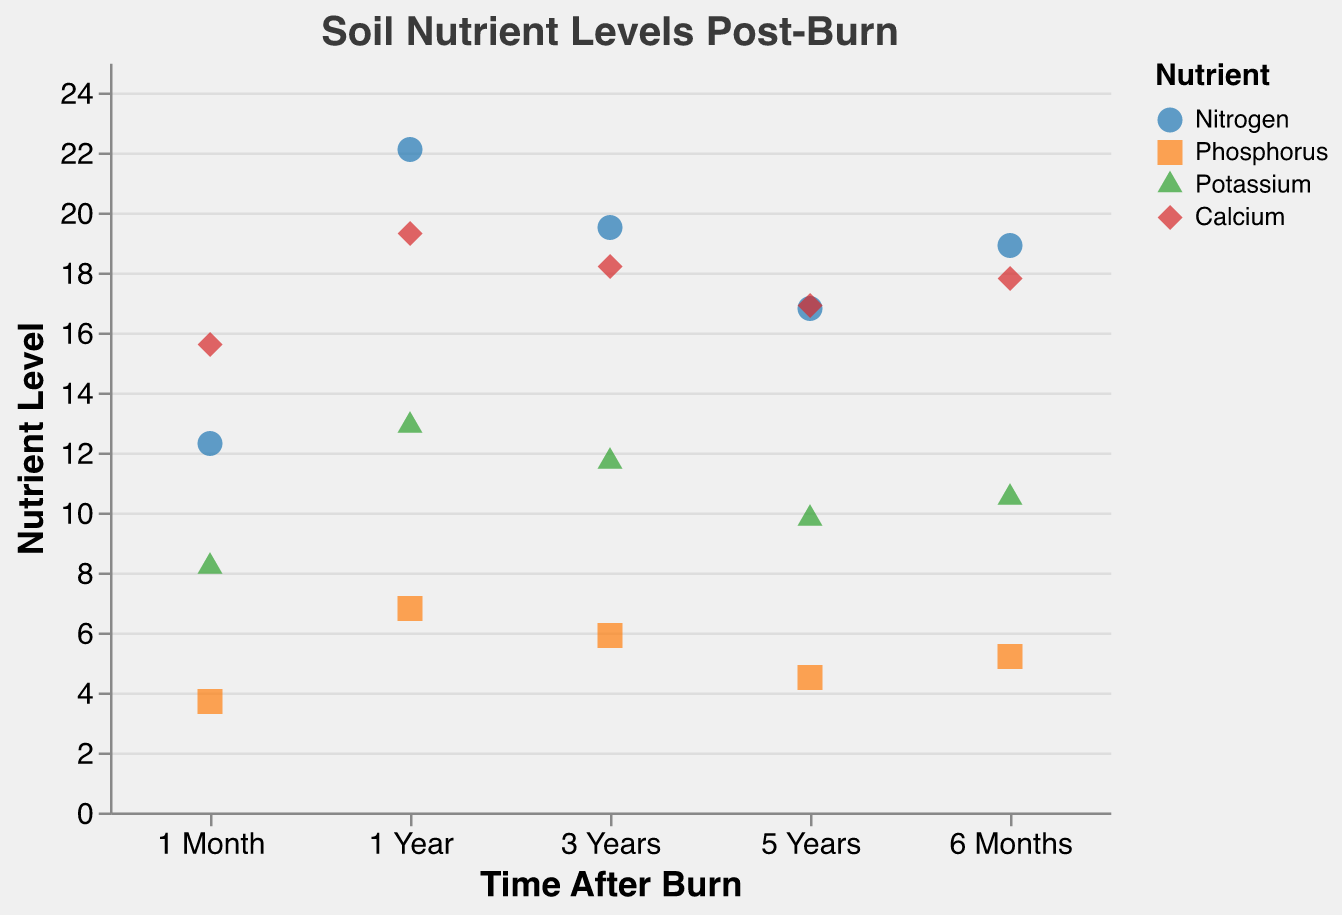What is the nutrient level of Nitrogen 1 Month after the burn? Locate the "Nitrogen" points on the figure and find the one corresponding to "1 Month". The value is labeled at the intersection of the "Time After Burn" axis and the "Nutrient Level" axis.
Answer: 12.3 Which nutrient has the highest level at 1 Year post-burn? Look at all nutrient levels for "1 Year" by matching the "1 Year" interval on the x-axis with the corresponding nutrient levels on the y-axis. Compare the values for each nutrient.
Answer: Nitrogen What is the difference in Nitrogen levels between 6 Months and 3 Years post-burn? Find the Nitrogen levels for both "6 Months" and "3 Years" by locating the data points on the plot. Subtract the level at "3 Years" from "6 Months".
Answer: -0.6 (19.5 - 18.9) Which time interval shows the highest Calcium level, and what is that level? Examine the Calcium points across all time intervals and identify the highest y-axis value.
Answer: 1 Year, 19.3 What is the average Phosphorus level across all time intervals? Sum the Phosphorus levels at each time interval: (3.7 + 5.2 + 6.8 + 5.9 + 4.5). Divide the sum by the number of intervals (5).
Answer: 5.22 How does the Phosphorus level at 6 Months compare to that at 5 Years? Identify the Phosphorus points for both "6 Months" and "5 Years". Compare the y-axis values.
Answer: Higher at 6 Months (5.2 vs 4.5) Which nutrient shows the least variability in levels over time? Examine the spread of data points for each nutrient and assess which has the smallest range from lowest to highest values.
Answer: Calcium What can you infer about the Potassium levels over the 5 Years post-burn? Observe the trend of Potassium levels at "1 Month," "6 Months," "1 Year," "3 Years," and "5 Years" to identify any patterns or changes.
Answer: Initial increase, peaking at 1 Year, followed by a decline Which nutrient shows a peak at 1 Year and drops again at 3 Years? Identify the nutrients with increasing levels up to "1 Year" followed by a decrease at "3 Years."
Answer: Nitrogen Is there a noticeable trend in Nitrogen level over the studied time intervals? Examine Nitrogen points at each time interval to identify if the levels are increasing, decreasing, or showing any specific pattern.
Answer: Increasing till 1 Year, then a decline 